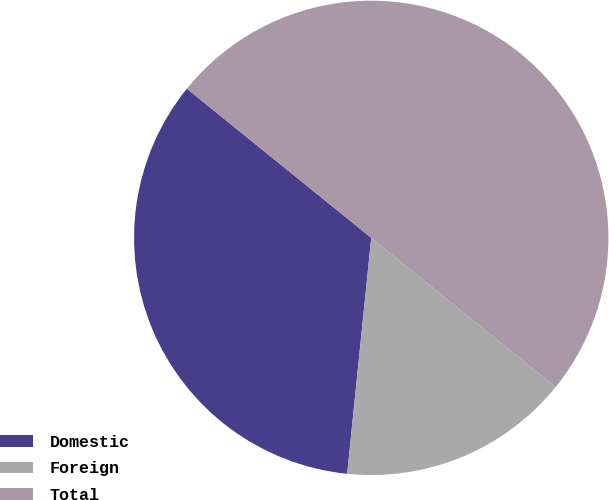Convert chart to OTSL. <chart><loc_0><loc_0><loc_500><loc_500><pie_chart><fcel>Domestic<fcel>Foreign<fcel>Total<nl><fcel>34.21%<fcel>15.79%<fcel>50.0%<nl></chart> 